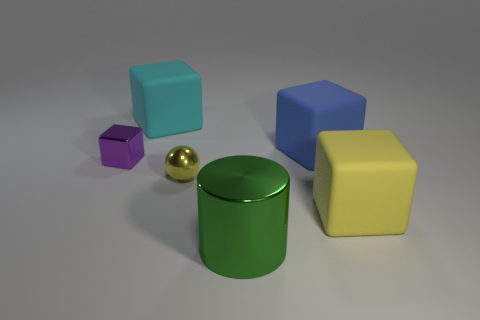Subtract all cyan cubes. How many cubes are left? 3 Add 2 large blue matte cylinders. How many objects exist? 8 Subtract all yellow blocks. How many blocks are left? 3 Subtract all blue cubes. How many blue spheres are left? 0 Subtract all gray balls. Subtract all cyan cylinders. How many balls are left? 1 Subtract all large yellow rubber blocks. Subtract all yellow blocks. How many objects are left? 4 Add 2 tiny purple cubes. How many tiny purple cubes are left? 3 Add 6 shiny spheres. How many shiny spheres exist? 7 Subtract 0 red spheres. How many objects are left? 6 Subtract all cubes. How many objects are left? 2 